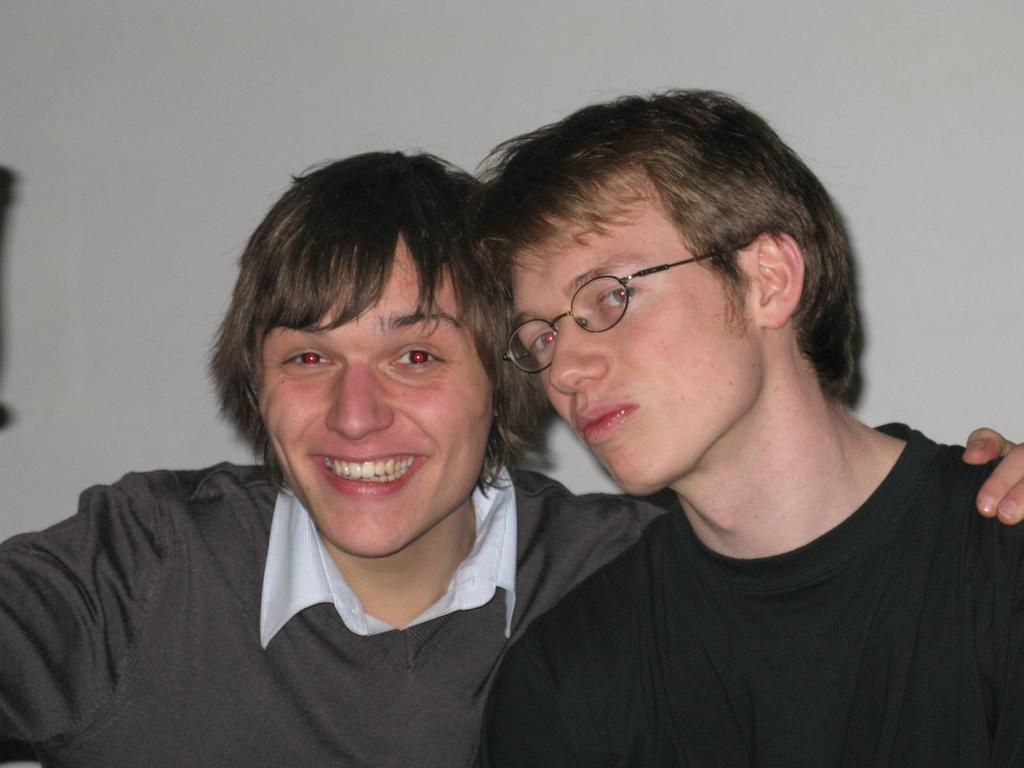How many men are in the image? There are two men in the image. What are the men wearing? One man is wearing a black t-shirt, and the other man is wearing a white shirt. What is the expression of the man with the white shirt? The man with the white shirt is smiling. What can be seen in the background of the image? There is a wall in the background of the image. What type of stitch is being used to sew the feast in the image? There is no feast or stitching present in the image. In which direction are the men facing in the image? The provided facts do not mention the direction the men are facing, so we cannot definitively answer this question. 